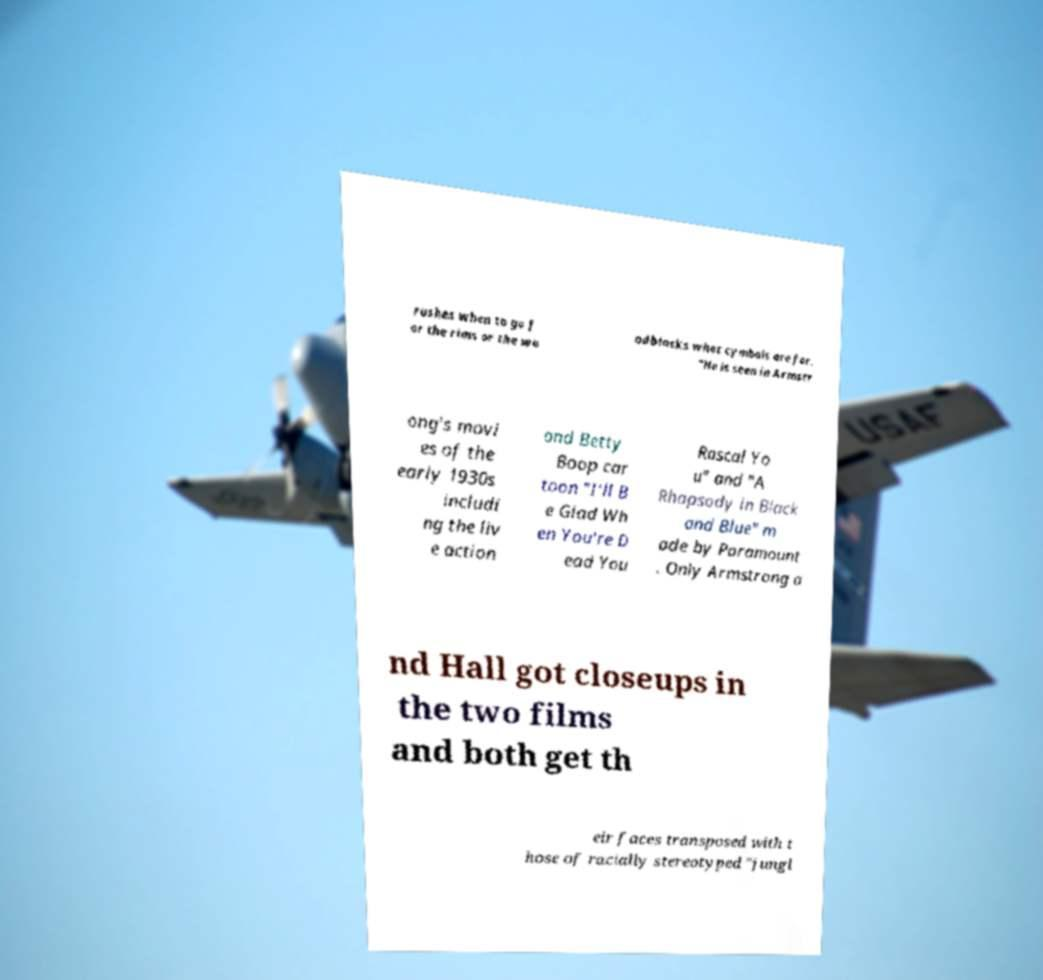Can you read and provide the text displayed in the image?This photo seems to have some interesting text. Can you extract and type it out for me? rushes when to go f or the rims or the wo odblocks what cymbals are for. "He is seen in Armstr ong's movi es of the early 1930s includi ng the liv e action and Betty Boop car toon "I'll B e Glad Wh en You're D ead You Rascal Yo u" and "A Rhapsody in Black and Blue" m ade by Paramount . Only Armstrong a nd Hall got closeups in the two films and both get th eir faces transposed with t hose of racially stereotyped "jungl 